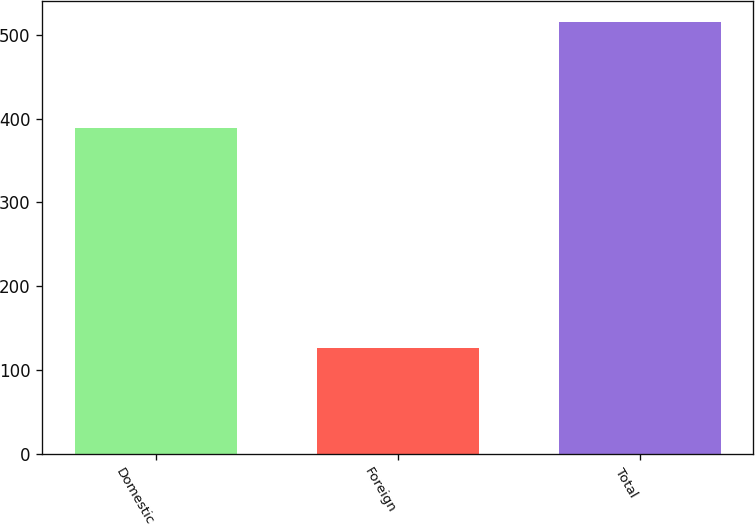<chart> <loc_0><loc_0><loc_500><loc_500><bar_chart><fcel>Domestic<fcel>Foreign<fcel>Total<nl><fcel>388.5<fcel>126.7<fcel>515.2<nl></chart> 